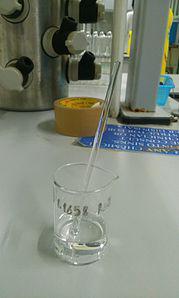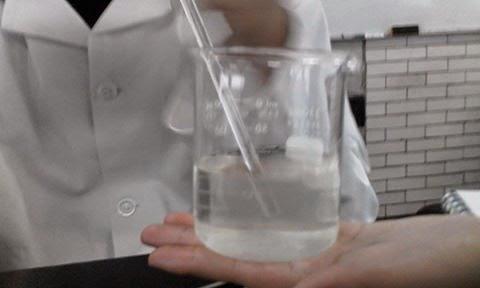The first image is the image on the left, the second image is the image on the right. For the images shown, is this caption "A long thin glass stick is in at least one beaker." true? Answer yes or no. Yes. The first image is the image on the left, the second image is the image on the right. Given the left and right images, does the statement "At least one of the photos contains three or more pieces of glassware." hold true? Answer yes or no. No. 